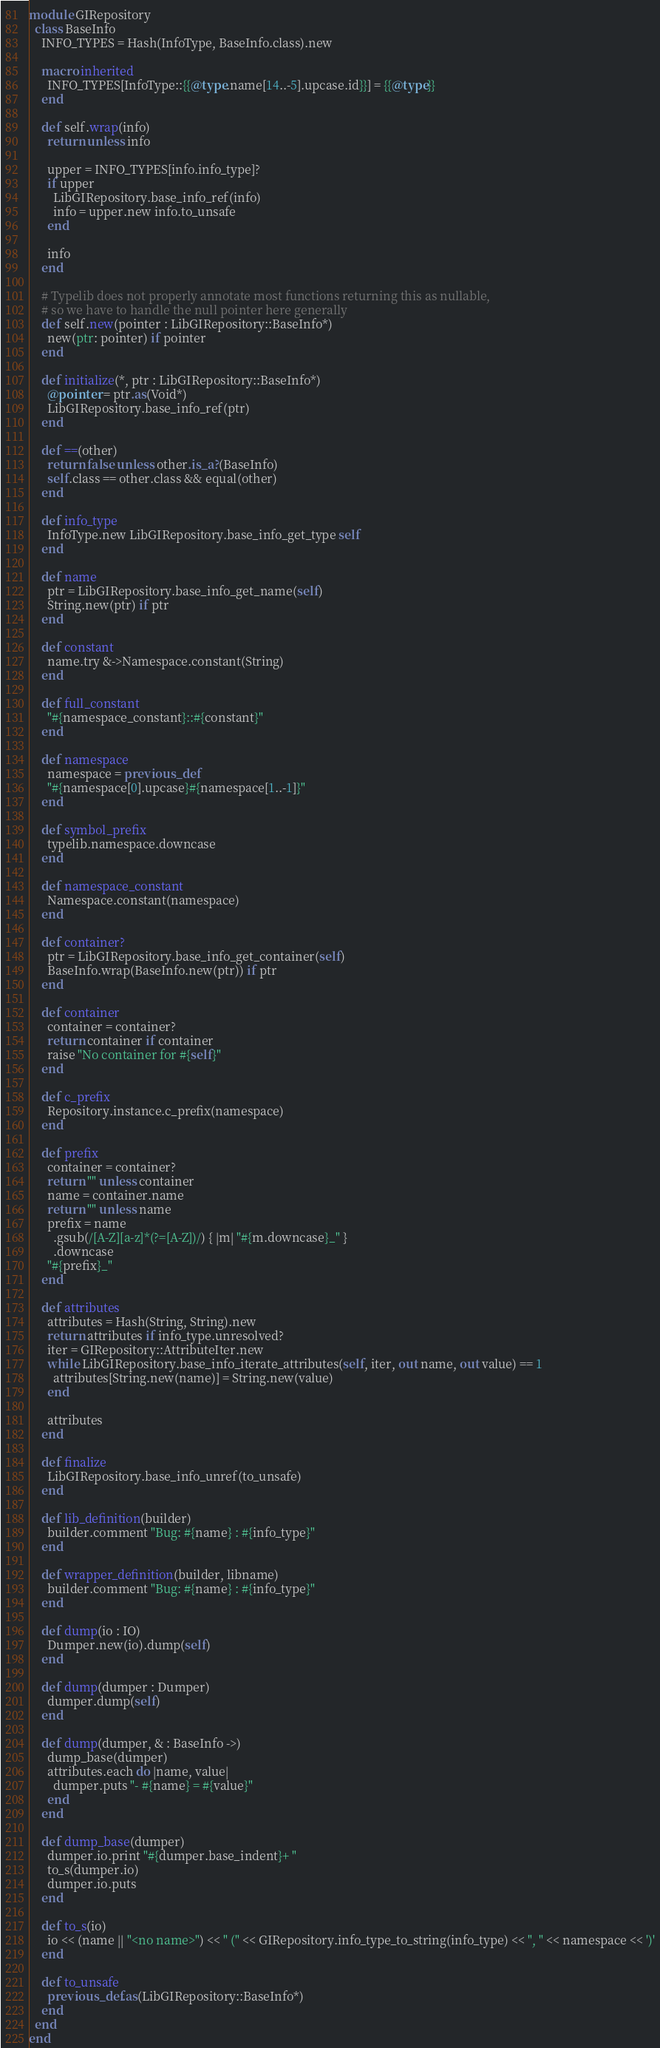Convert code to text. <code><loc_0><loc_0><loc_500><loc_500><_Crystal_>module GIRepository
  class BaseInfo
    INFO_TYPES = Hash(InfoType, BaseInfo.class).new

    macro inherited
      INFO_TYPES[InfoType::{{@type.name[14..-5].upcase.id}}] = {{@type}}
    end

    def self.wrap(info)
      return unless info

      upper = INFO_TYPES[info.info_type]?
      if upper
        LibGIRepository.base_info_ref(info)
        info = upper.new info.to_unsafe
      end

      info
    end

    # Typelib does not properly annotate most functions returning this as nullable,
    # so we have to handle the null pointer here generally
    def self.new(pointer : LibGIRepository::BaseInfo*)
      new(ptr: pointer) if pointer
    end

    def initialize(*, ptr : LibGIRepository::BaseInfo*)
      @pointer = ptr.as(Void*)
      LibGIRepository.base_info_ref(ptr)
    end

    def ==(other)
      return false unless other.is_a?(BaseInfo)
      self.class == other.class && equal(other)
    end

    def info_type
      InfoType.new LibGIRepository.base_info_get_type self
    end

    def name
      ptr = LibGIRepository.base_info_get_name(self)
      String.new(ptr) if ptr
    end

    def constant
      name.try &->Namespace.constant(String)
    end

    def full_constant
      "#{namespace_constant}::#{constant}"
    end

    def namespace
      namespace = previous_def
      "#{namespace[0].upcase}#{namespace[1..-1]}"
    end

    def symbol_prefix
      typelib.namespace.downcase
    end

    def namespace_constant
      Namespace.constant(namespace)
    end

    def container?
      ptr = LibGIRepository.base_info_get_container(self)
      BaseInfo.wrap(BaseInfo.new(ptr)) if ptr
    end

    def container
      container = container?
      return container if container
      raise "No container for #{self}"
    end

    def c_prefix
      Repository.instance.c_prefix(namespace)
    end

    def prefix
      container = container?
      return "" unless container
      name = container.name
      return "" unless name
      prefix = name
        .gsub(/[A-Z][a-z]*(?=[A-Z])/) { |m| "#{m.downcase}_" }
        .downcase
      "#{prefix}_"
    end

    def attributes
      attributes = Hash(String, String).new
      return attributes if info_type.unresolved?
      iter = GIRepository::AttributeIter.new
      while LibGIRepository.base_info_iterate_attributes(self, iter, out name, out value) == 1
        attributes[String.new(name)] = String.new(value)
      end

      attributes
    end

    def finalize
      LibGIRepository.base_info_unref(to_unsafe)
    end

    def lib_definition(builder)
      builder.comment "Bug: #{name} : #{info_type}"
    end

    def wrapper_definition(builder, libname)
      builder.comment "Bug: #{name} : #{info_type}"
    end

    def dump(io : IO)
      Dumper.new(io).dump(self)
    end

    def dump(dumper : Dumper)
      dumper.dump(self)
    end

    def dump(dumper, & : BaseInfo ->)
      dump_base(dumper)
      attributes.each do |name, value|
        dumper.puts "- #{name} = #{value}"
      end
    end

    def dump_base(dumper)
      dumper.io.print "#{dumper.base_indent}+ "
      to_s(dumper.io)
      dumper.io.puts
    end

    def to_s(io)
      io << (name || "<no name>") << " (" << GIRepository.info_type_to_string(info_type) << ", " << namespace << ')'
    end

    def to_unsafe
      previous_def.as(LibGIRepository::BaseInfo*)
    end
  end
end
</code> 